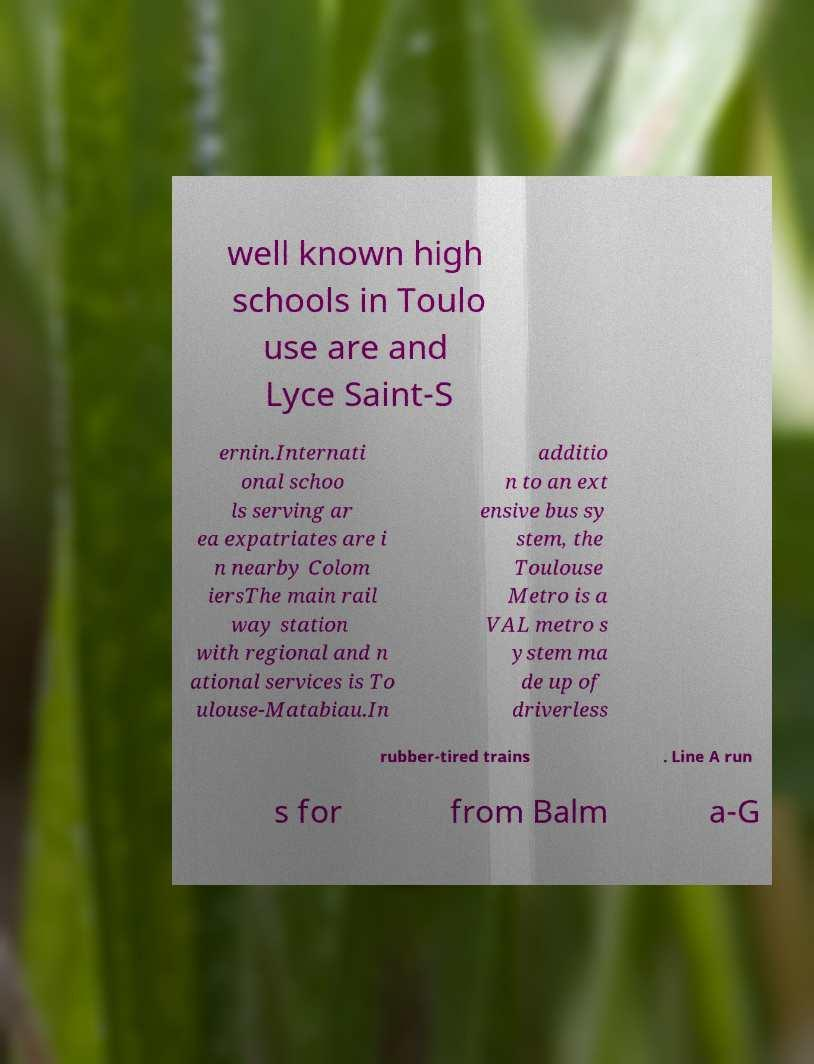There's text embedded in this image that I need extracted. Can you transcribe it verbatim? well known high schools in Toulo use are and Lyce Saint-S ernin.Internati onal schoo ls serving ar ea expatriates are i n nearby Colom iersThe main rail way station with regional and n ational services is To ulouse-Matabiau.In additio n to an ext ensive bus sy stem, the Toulouse Metro is a VAL metro s ystem ma de up of driverless rubber-tired trains . Line A run s for from Balm a-G 